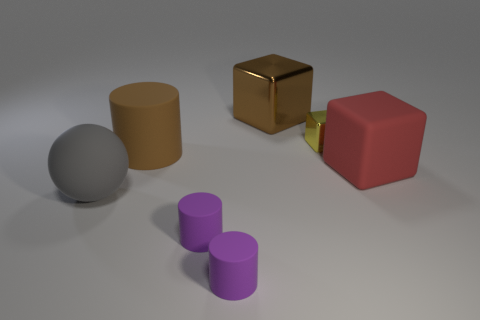Subtract all purple cubes. Subtract all cyan cylinders. How many cubes are left? 3 Add 1 red objects. How many objects exist? 8 Subtract all cylinders. How many objects are left? 4 Add 6 tiny rubber spheres. How many tiny rubber spheres exist? 6 Subtract 0 blue cubes. How many objects are left? 7 Subtract all tiny purple cylinders. Subtract all yellow cubes. How many objects are left? 4 Add 3 big rubber things. How many big rubber things are left? 6 